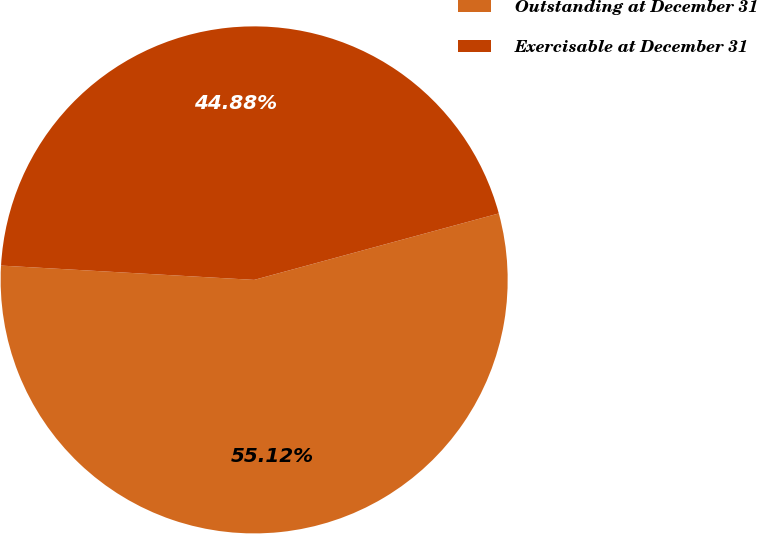Convert chart to OTSL. <chart><loc_0><loc_0><loc_500><loc_500><pie_chart><fcel>Outstanding at December 31<fcel>Exercisable at December 31<nl><fcel>55.12%<fcel>44.88%<nl></chart> 